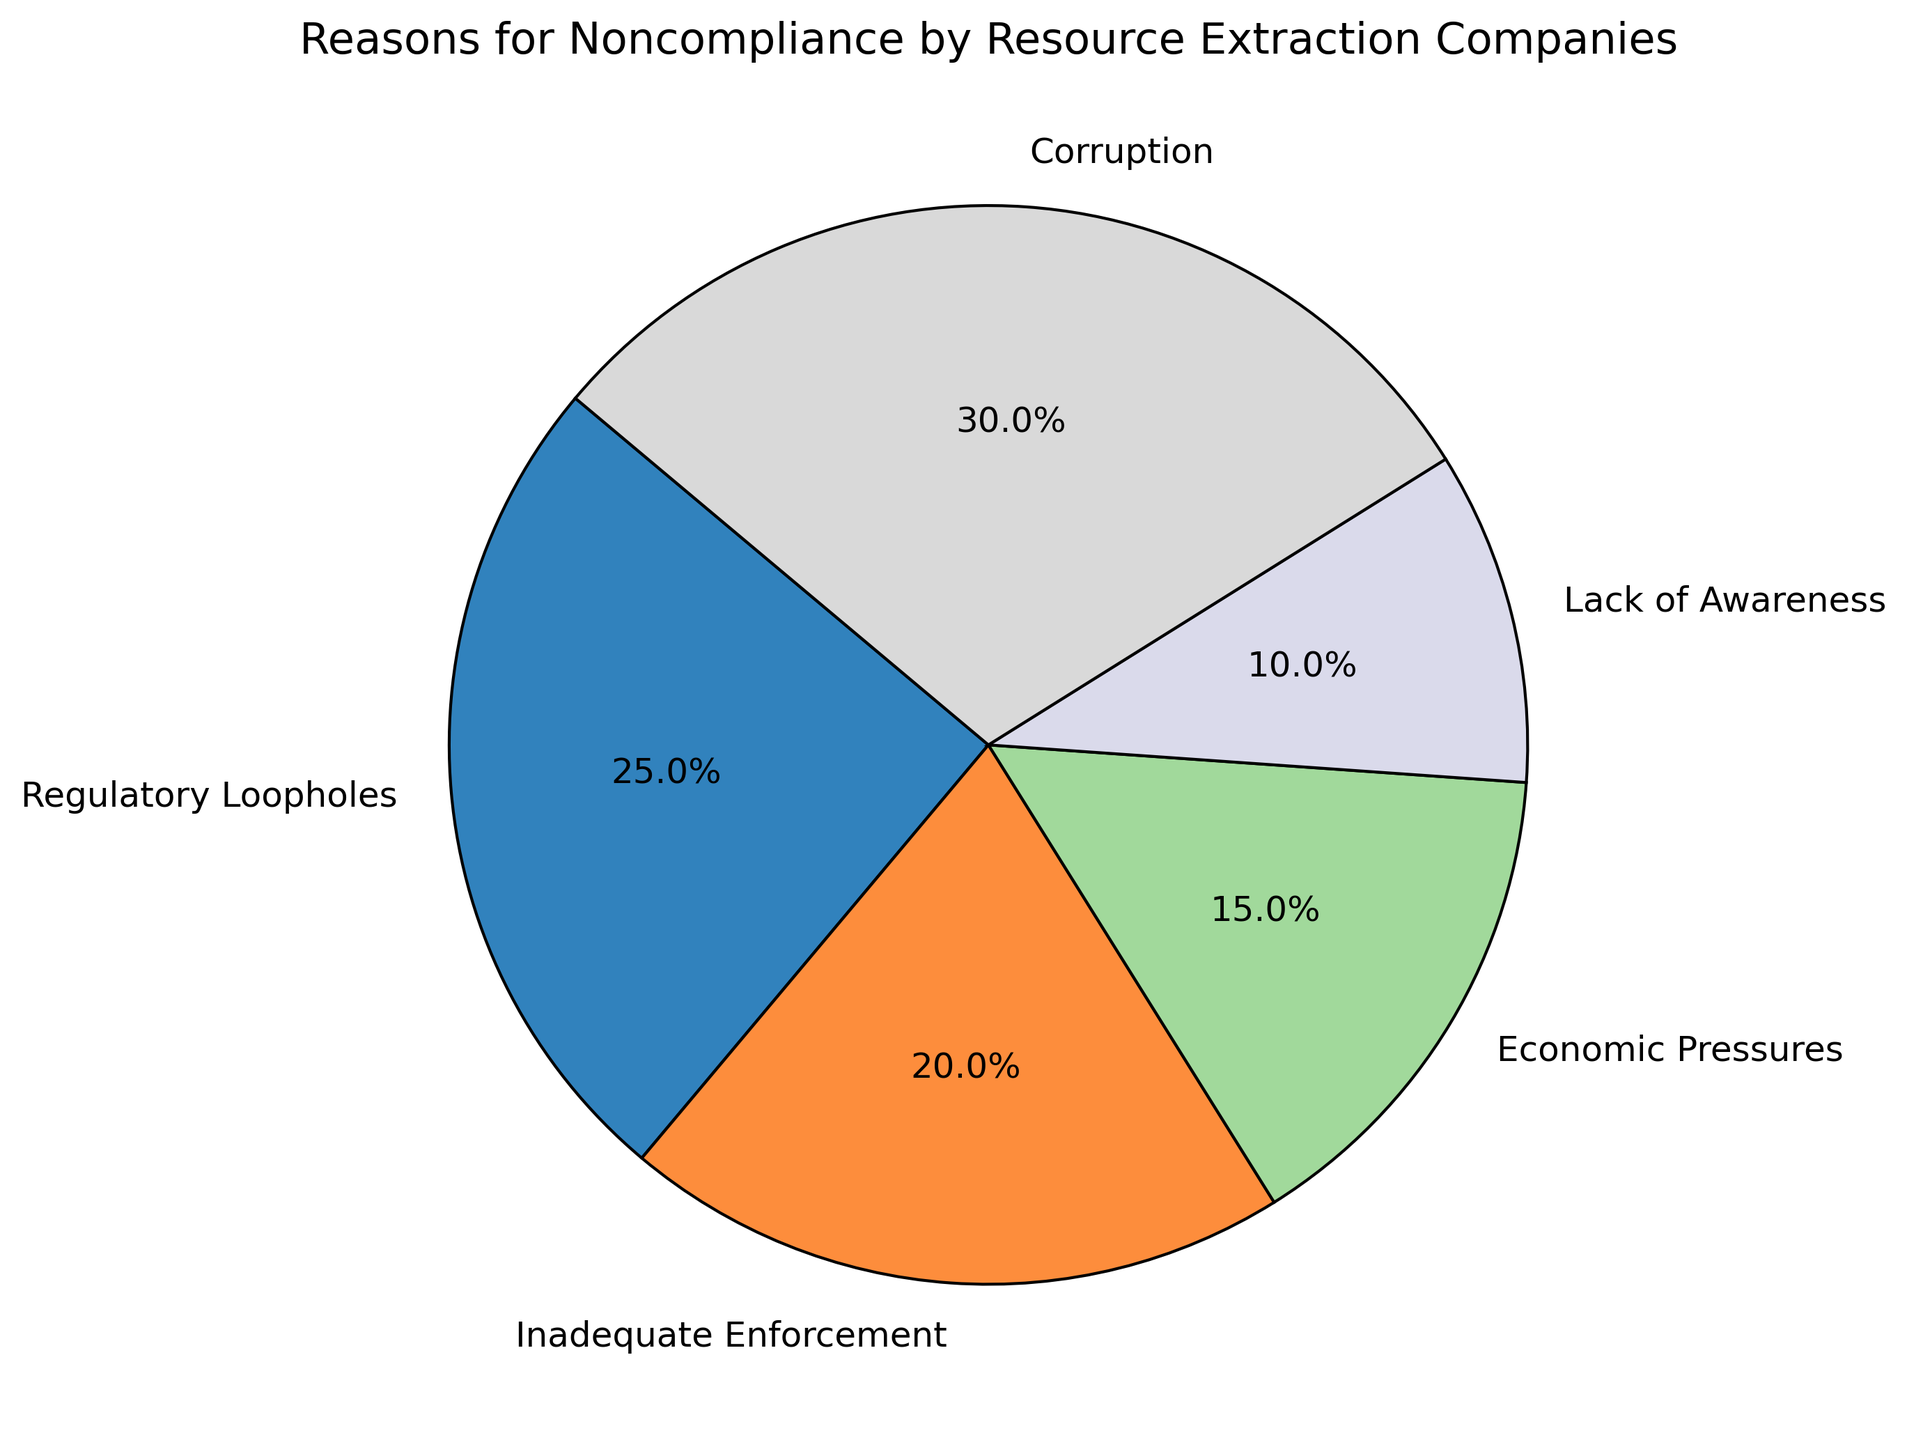Which reason for noncompliance has the highest percentage? Locate the segment with the highest percentage label around the pie chart. The segment labeled "Corruption" has the highest value at 30%.
Answer: Corruption Which reason for noncompliance is the least common? Identify the segment with the lowest percentage label around the pie chart. The segment labeled "Lack of Awareness" has the lowest value at 10%.
Answer: Lack of Awareness How much more does Corruption contribute to noncompliance than Economic Pressures? Subtract the percentage of Economic Pressures from the percentage of Corruption: 30% - 15% = 15%.
Answer: 15% What percentage of noncompliance is due to reasons other than Corruption and Regulatory Loopholes? Sum the remaining percentages besides Corruption and Regulatory Loopholes: 20% + 15% + 10% = 45%.
Answer: 45% What is the combined percentage for Inadequate Enforcement and Economic Pressures? Add the percentages of Inadequate Enforcement and Economic Pressures: 20% + 15% = 35%.
Answer: 35% Is Lack of Awareness more common than Economic Pressures based on the percentages? Compare the percentages for Lack of Awareness and Economic Pressures: 10% is less than 15%, so no.
Answer: No What is the average percentage of all reasons for noncompliance? Sum the percentages and divide by the number of reasons: (25% + 20% + 15% + 10% + 30%) / 5 = 100% / 5 = 20%.
Answer: 20% Which two reasons for noncompliance combined have the same total percentage as Corruption? Find two segments whose combined percentages equal 30%. Inadequate Enforcement (20%) and Lack of Awareness (10%) together total 30%.
Answer: Inadequate Enforcement and Lack of Awareness What is the difference in percentage between Regulatory Loopholes and Inadequate Enforcement? Subtract the percentage of Inadequate Enforcement from the percentage of Regulatory Loopholes: 25% - 20% = 5%.
Answer: 5% Is the sum of the percentages for Lack of Awareness and Economic Pressures greater than the percentage for Regulatory Loopholes? Calculate the sum of Lack of Awareness and Economic Pressures: 10% + 15% = 25%. Compare this to Regulatory Loopholes (25%): they are equal, so no.
Answer: No 